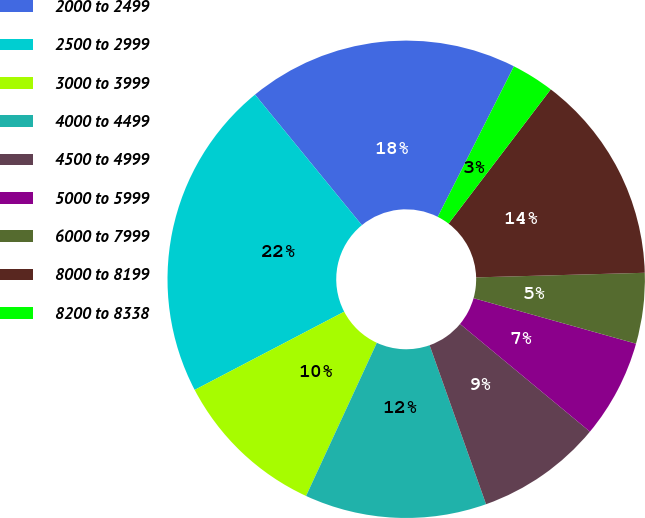Convert chart. <chart><loc_0><loc_0><loc_500><loc_500><pie_chart><fcel>2000 to 2499<fcel>2500 to 2999<fcel>3000 to 3999<fcel>4000 to 4499<fcel>4500 to 4999<fcel>5000 to 5999<fcel>6000 to 7999<fcel>8000 to 8199<fcel>8200 to 8338<nl><fcel>18.37%<fcel>21.75%<fcel>10.44%<fcel>12.32%<fcel>8.55%<fcel>6.67%<fcel>4.78%<fcel>14.21%<fcel>2.9%<nl></chart> 